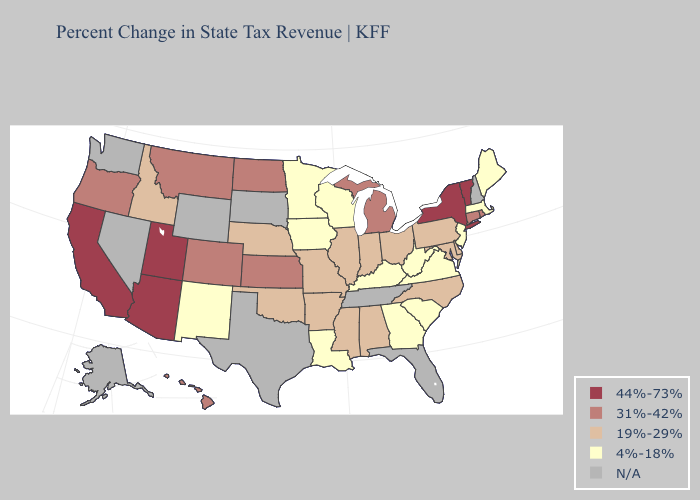What is the lowest value in states that border West Virginia?
Concise answer only. 4%-18%. Does Kentucky have the highest value in the South?
Be succinct. No. What is the value of North Dakota?
Short answer required. 31%-42%. Among the states that border North Dakota , does Minnesota have the highest value?
Answer briefly. No. Name the states that have a value in the range N/A?
Quick response, please. Alaska, Florida, Nevada, New Hampshire, South Dakota, Tennessee, Texas, Washington, Wyoming. Does the map have missing data?
Write a very short answer. Yes. Which states hav the highest value in the South?
Concise answer only. Alabama, Arkansas, Delaware, Maryland, Mississippi, North Carolina, Oklahoma. Name the states that have a value in the range 19%-29%?
Short answer required. Alabama, Arkansas, Delaware, Idaho, Illinois, Indiana, Maryland, Mississippi, Missouri, Nebraska, North Carolina, Ohio, Oklahoma, Pennsylvania. What is the value of Oregon?
Concise answer only. 31%-42%. What is the lowest value in states that border Nevada?
Be succinct. 19%-29%. What is the value of Rhode Island?
Short answer required. 31%-42%. Does California have the highest value in the USA?
Be succinct. Yes. Does California have the lowest value in the USA?
Quick response, please. No. Does Delaware have the highest value in the USA?
Give a very brief answer. No. Among the states that border Mississippi , which have the highest value?
Be succinct. Alabama, Arkansas. 